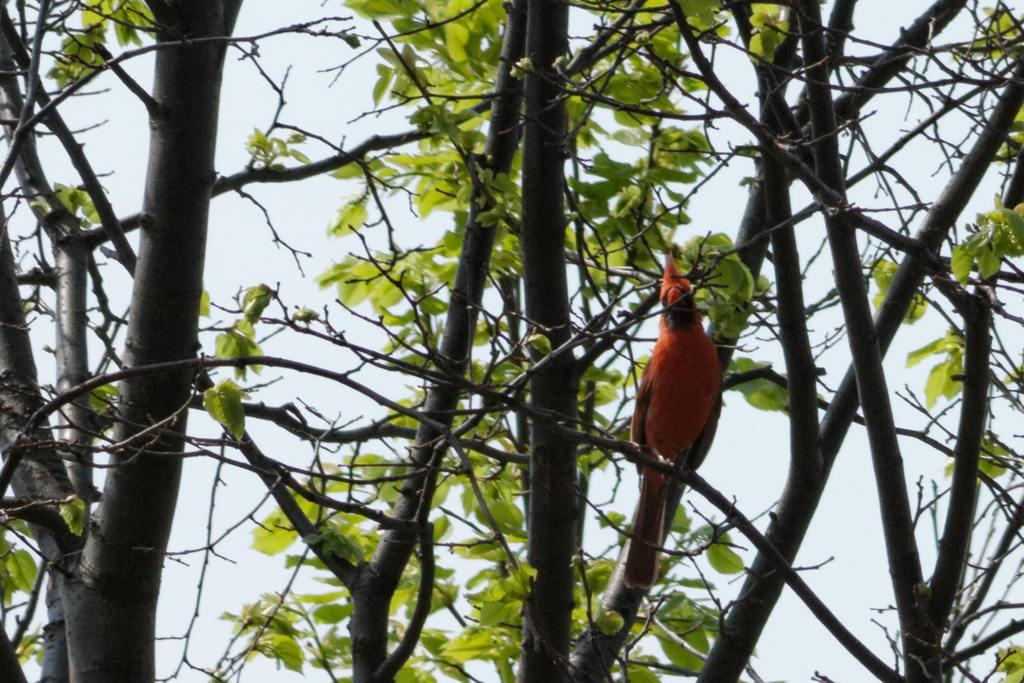In one or two sentences, can you explain what this image depicts? In the foreground of this image, there is an orange colored parrot on the branches of a tree. In the background, we can see the sky. 